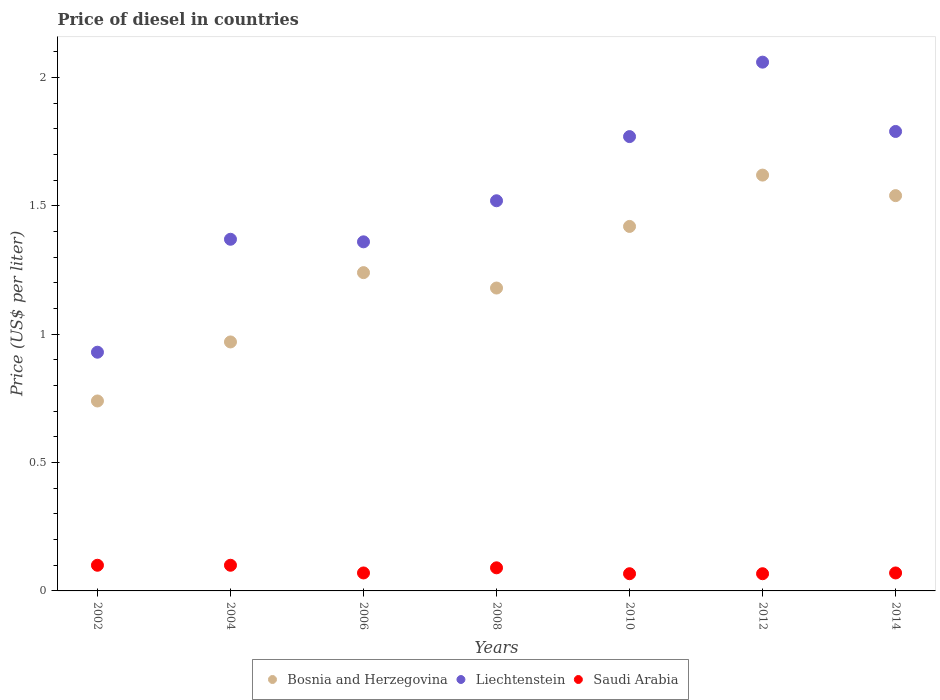How many different coloured dotlines are there?
Your answer should be very brief. 3. What is the price of diesel in Bosnia and Herzegovina in 2014?
Give a very brief answer. 1.54. Across all years, what is the maximum price of diesel in Bosnia and Herzegovina?
Your answer should be compact. 1.62. Across all years, what is the minimum price of diesel in Saudi Arabia?
Your response must be concise. 0.07. What is the total price of diesel in Bosnia and Herzegovina in the graph?
Keep it short and to the point. 8.71. What is the difference between the price of diesel in Saudi Arabia in 2006 and that in 2012?
Provide a succinct answer. 0. What is the difference between the price of diesel in Bosnia and Herzegovina in 2004 and the price of diesel in Saudi Arabia in 2012?
Your response must be concise. 0.9. What is the average price of diesel in Bosnia and Herzegovina per year?
Offer a terse response. 1.24. In the year 2014, what is the difference between the price of diesel in Saudi Arabia and price of diesel in Bosnia and Herzegovina?
Provide a succinct answer. -1.47. What is the ratio of the price of diesel in Bosnia and Herzegovina in 2002 to that in 2012?
Your answer should be compact. 0.46. Is the price of diesel in Saudi Arabia in 2002 less than that in 2014?
Provide a short and direct response. No. What is the difference between the highest and the second highest price of diesel in Liechtenstein?
Keep it short and to the point. 0.27. What is the difference between the highest and the lowest price of diesel in Saudi Arabia?
Your response must be concise. 0.03. In how many years, is the price of diesel in Bosnia and Herzegovina greater than the average price of diesel in Bosnia and Herzegovina taken over all years?
Provide a short and direct response. 3. Is it the case that in every year, the sum of the price of diesel in Bosnia and Herzegovina and price of diesel in Saudi Arabia  is greater than the price of diesel in Liechtenstein?
Offer a terse response. No. Does the price of diesel in Liechtenstein monotonically increase over the years?
Offer a very short reply. No. How many dotlines are there?
Your response must be concise. 3. How are the legend labels stacked?
Provide a succinct answer. Horizontal. What is the title of the graph?
Your answer should be very brief. Price of diesel in countries. What is the label or title of the X-axis?
Offer a very short reply. Years. What is the label or title of the Y-axis?
Offer a terse response. Price (US$ per liter). What is the Price (US$ per liter) of Bosnia and Herzegovina in 2002?
Provide a succinct answer. 0.74. What is the Price (US$ per liter) in Liechtenstein in 2002?
Offer a very short reply. 0.93. What is the Price (US$ per liter) in Saudi Arabia in 2002?
Offer a very short reply. 0.1. What is the Price (US$ per liter) of Bosnia and Herzegovina in 2004?
Offer a terse response. 0.97. What is the Price (US$ per liter) in Liechtenstein in 2004?
Ensure brevity in your answer.  1.37. What is the Price (US$ per liter) of Bosnia and Herzegovina in 2006?
Provide a short and direct response. 1.24. What is the Price (US$ per liter) in Liechtenstein in 2006?
Provide a short and direct response. 1.36. What is the Price (US$ per liter) of Saudi Arabia in 2006?
Offer a terse response. 0.07. What is the Price (US$ per liter) of Bosnia and Herzegovina in 2008?
Your answer should be compact. 1.18. What is the Price (US$ per liter) in Liechtenstein in 2008?
Offer a very short reply. 1.52. What is the Price (US$ per liter) in Saudi Arabia in 2008?
Your answer should be very brief. 0.09. What is the Price (US$ per liter) of Bosnia and Herzegovina in 2010?
Give a very brief answer. 1.42. What is the Price (US$ per liter) of Liechtenstein in 2010?
Provide a short and direct response. 1.77. What is the Price (US$ per liter) in Saudi Arabia in 2010?
Your response must be concise. 0.07. What is the Price (US$ per liter) in Bosnia and Herzegovina in 2012?
Make the answer very short. 1.62. What is the Price (US$ per liter) of Liechtenstein in 2012?
Offer a terse response. 2.06. What is the Price (US$ per liter) in Saudi Arabia in 2012?
Keep it short and to the point. 0.07. What is the Price (US$ per liter) in Bosnia and Herzegovina in 2014?
Make the answer very short. 1.54. What is the Price (US$ per liter) of Liechtenstein in 2014?
Provide a short and direct response. 1.79. What is the Price (US$ per liter) of Saudi Arabia in 2014?
Offer a terse response. 0.07. Across all years, what is the maximum Price (US$ per liter) in Bosnia and Herzegovina?
Keep it short and to the point. 1.62. Across all years, what is the maximum Price (US$ per liter) of Liechtenstein?
Ensure brevity in your answer.  2.06. Across all years, what is the maximum Price (US$ per liter) in Saudi Arabia?
Provide a succinct answer. 0.1. Across all years, what is the minimum Price (US$ per liter) of Bosnia and Herzegovina?
Provide a short and direct response. 0.74. Across all years, what is the minimum Price (US$ per liter) in Saudi Arabia?
Provide a short and direct response. 0.07. What is the total Price (US$ per liter) in Bosnia and Herzegovina in the graph?
Your response must be concise. 8.71. What is the total Price (US$ per liter) in Saudi Arabia in the graph?
Ensure brevity in your answer.  0.56. What is the difference between the Price (US$ per liter) in Bosnia and Herzegovina in 2002 and that in 2004?
Provide a succinct answer. -0.23. What is the difference between the Price (US$ per liter) of Liechtenstein in 2002 and that in 2004?
Your response must be concise. -0.44. What is the difference between the Price (US$ per liter) in Bosnia and Herzegovina in 2002 and that in 2006?
Offer a terse response. -0.5. What is the difference between the Price (US$ per liter) of Liechtenstein in 2002 and that in 2006?
Make the answer very short. -0.43. What is the difference between the Price (US$ per liter) in Saudi Arabia in 2002 and that in 2006?
Provide a succinct answer. 0.03. What is the difference between the Price (US$ per liter) in Bosnia and Herzegovina in 2002 and that in 2008?
Offer a terse response. -0.44. What is the difference between the Price (US$ per liter) in Liechtenstein in 2002 and that in 2008?
Your response must be concise. -0.59. What is the difference between the Price (US$ per liter) in Saudi Arabia in 2002 and that in 2008?
Ensure brevity in your answer.  0.01. What is the difference between the Price (US$ per liter) of Bosnia and Herzegovina in 2002 and that in 2010?
Keep it short and to the point. -0.68. What is the difference between the Price (US$ per liter) of Liechtenstein in 2002 and that in 2010?
Keep it short and to the point. -0.84. What is the difference between the Price (US$ per liter) in Saudi Arabia in 2002 and that in 2010?
Keep it short and to the point. 0.03. What is the difference between the Price (US$ per liter) of Bosnia and Herzegovina in 2002 and that in 2012?
Provide a succinct answer. -0.88. What is the difference between the Price (US$ per liter) of Liechtenstein in 2002 and that in 2012?
Your answer should be compact. -1.13. What is the difference between the Price (US$ per liter) of Saudi Arabia in 2002 and that in 2012?
Your answer should be very brief. 0.03. What is the difference between the Price (US$ per liter) in Liechtenstein in 2002 and that in 2014?
Keep it short and to the point. -0.86. What is the difference between the Price (US$ per liter) of Saudi Arabia in 2002 and that in 2014?
Your response must be concise. 0.03. What is the difference between the Price (US$ per liter) of Bosnia and Herzegovina in 2004 and that in 2006?
Ensure brevity in your answer.  -0.27. What is the difference between the Price (US$ per liter) of Bosnia and Herzegovina in 2004 and that in 2008?
Make the answer very short. -0.21. What is the difference between the Price (US$ per liter) of Saudi Arabia in 2004 and that in 2008?
Provide a succinct answer. 0.01. What is the difference between the Price (US$ per liter) in Bosnia and Herzegovina in 2004 and that in 2010?
Your answer should be compact. -0.45. What is the difference between the Price (US$ per liter) of Liechtenstein in 2004 and that in 2010?
Keep it short and to the point. -0.4. What is the difference between the Price (US$ per liter) in Saudi Arabia in 2004 and that in 2010?
Provide a succinct answer. 0.03. What is the difference between the Price (US$ per liter) in Bosnia and Herzegovina in 2004 and that in 2012?
Provide a succinct answer. -0.65. What is the difference between the Price (US$ per liter) in Liechtenstein in 2004 and that in 2012?
Your answer should be very brief. -0.69. What is the difference between the Price (US$ per liter) in Saudi Arabia in 2004 and that in 2012?
Ensure brevity in your answer.  0.03. What is the difference between the Price (US$ per liter) in Bosnia and Herzegovina in 2004 and that in 2014?
Keep it short and to the point. -0.57. What is the difference between the Price (US$ per liter) in Liechtenstein in 2004 and that in 2014?
Provide a succinct answer. -0.42. What is the difference between the Price (US$ per liter) of Saudi Arabia in 2004 and that in 2014?
Keep it short and to the point. 0.03. What is the difference between the Price (US$ per liter) of Liechtenstein in 2006 and that in 2008?
Keep it short and to the point. -0.16. What is the difference between the Price (US$ per liter) of Saudi Arabia in 2006 and that in 2008?
Offer a terse response. -0.02. What is the difference between the Price (US$ per liter) in Bosnia and Herzegovina in 2006 and that in 2010?
Provide a short and direct response. -0.18. What is the difference between the Price (US$ per liter) of Liechtenstein in 2006 and that in 2010?
Your answer should be compact. -0.41. What is the difference between the Price (US$ per liter) of Saudi Arabia in 2006 and that in 2010?
Ensure brevity in your answer.  0. What is the difference between the Price (US$ per liter) of Bosnia and Herzegovina in 2006 and that in 2012?
Offer a very short reply. -0.38. What is the difference between the Price (US$ per liter) in Saudi Arabia in 2006 and that in 2012?
Provide a short and direct response. 0. What is the difference between the Price (US$ per liter) in Bosnia and Herzegovina in 2006 and that in 2014?
Keep it short and to the point. -0.3. What is the difference between the Price (US$ per liter) of Liechtenstein in 2006 and that in 2014?
Your answer should be very brief. -0.43. What is the difference between the Price (US$ per liter) of Saudi Arabia in 2006 and that in 2014?
Make the answer very short. 0. What is the difference between the Price (US$ per liter) in Bosnia and Herzegovina in 2008 and that in 2010?
Provide a short and direct response. -0.24. What is the difference between the Price (US$ per liter) in Saudi Arabia in 2008 and that in 2010?
Your answer should be compact. 0.02. What is the difference between the Price (US$ per liter) in Bosnia and Herzegovina in 2008 and that in 2012?
Give a very brief answer. -0.44. What is the difference between the Price (US$ per liter) of Liechtenstein in 2008 and that in 2012?
Your response must be concise. -0.54. What is the difference between the Price (US$ per liter) in Saudi Arabia in 2008 and that in 2012?
Provide a short and direct response. 0.02. What is the difference between the Price (US$ per liter) of Bosnia and Herzegovina in 2008 and that in 2014?
Your response must be concise. -0.36. What is the difference between the Price (US$ per liter) in Liechtenstein in 2008 and that in 2014?
Your answer should be very brief. -0.27. What is the difference between the Price (US$ per liter) of Liechtenstein in 2010 and that in 2012?
Provide a succinct answer. -0.29. What is the difference between the Price (US$ per liter) of Saudi Arabia in 2010 and that in 2012?
Keep it short and to the point. 0. What is the difference between the Price (US$ per liter) of Bosnia and Herzegovina in 2010 and that in 2014?
Ensure brevity in your answer.  -0.12. What is the difference between the Price (US$ per liter) in Liechtenstein in 2010 and that in 2014?
Give a very brief answer. -0.02. What is the difference between the Price (US$ per liter) of Saudi Arabia in 2010 and that in 2014?
Offer a very short reply. -0. What is the difference between the Price (US$ per liter) in Bosnia and Herzegovina in 2012 and that in 2014?
Your answer should be compact. 0.08. What is the difference between the Price (US$ per liter) of Liechtenstein in 2012 and that in 2014?
Your answer should be very brief. 0.27. What is the difference between the Price (US$ per liter) of Saudi Arabia in 2012 and that in 2014?
Offer a very short reply. -0. What is the difference between the Price (US$ per liter) of Bosnia and Herzegovina in 2002 and the Price (US$ per liter) of Liechtenstein in 2004?
Offer a terse response. -0.63. What is the difference between the Price (US$ per liter) of Bosnia and Herzegovina in 2002 and the Price (US$ per liter) of Saudi Arabia in 2004?
Ensure brevity in your answer.  0.64. What is the difference between the Price (US$ per liter) in Liechtenstein in 2002 and the Price (US$ per liter) in Saudi Arabia in 2004?
Provide a succinct answer. 0.83. What is the difference between the Price (US$ per liter) of Bosnia and Herzegovina in 2002 and the Price (US$ per liter) of Liechtenstein in 2006?
Your response must be concise. -0.62. What is the difference between the Price (US$ per liter) in Bosnia and Herzegovina in 2002 and the Price (US$ per liter) in Saudi Arabia in 2006?
Your answer should be very brief. 0.67. What is the difference between the Price (US$ per liter) in Liechtenstein in 2002 and the Price (US$ per liter) in Saudi Arabia in 2006?
Offer a terse response. 0.86. What is the difference between the Price (US$ per liter) in Bosnia and Herzegovina in 2002 and the Price (US$ per liter) in Liechtenstein in 2008?
Ensure brevity in your answer.  -0.78. What is the difference between the Price (US$ per liter) in Bosnia and Herzegovina in 2002 and the Price (US$ per liter) in Saudi Arabia in 2008?
Your answer should be very brief. 0.65. What is the difference between the Price (US$ per liter) in Liechtenstein in 2002 and the Price (US$ per liter) in Saudi Arabia in 2008?
Offer a very short reply. 0.84. What is the difference between the Price (US$ per liter) in Bosnia and Herzegovina in 2002 and the Price (US$ per liter) in Liechtenstein in 2010?
Your answer should be compact. -1.03. What is the difference between the Price (US$ per liter) of Bosnia and Herzegovina in 2002 and the Price (US$ per liter) of Saudi Arabia in 2010?
Your answer should be compact. 0.67. What is the difference between the Price (US$ per liter) in Liechtenstein in 2002 and the Price (US$ per liter) in Saudi Arabia in 2010?
Your response must be concise. 0.86. What is the difference between the Price (US$ per liter) in Bosnia and Herzegovina in 2002 and the Price (US$ per liter) in Liechtenstein in 2012?
Your response must be concise. -1.32. What is the difference between the Price (US$ per liter) in Bosnia and Herzegovina in 2002 and the Price (US$ per liter) in Saudi Arabia in 2012?
Keep it short and to the point. 0.67. What is the difference between the Price (US$ per liter) of Liechtenstein in 2002 and the Price (US$ per liter) of Saudi Arabia in 2012?
Your answer should be compact. 0.86. What is the difference between the Price (US$ per liter) of Bosnia and Herzegovina in 2002 and the Price (US$ per liter) of Liechtenstein in 2014?
Your answer should be very brief. -1.05. What is the difference between the Price (US$ per liter) of Bosnia and Herzegovina in 2002 and the Price (US$ per liter) of Saudi Arabia in 2014?
Ensure brevity in your answer.  0.67. What is the difference between the Price (US$ per liter) of Liechtenstein in 2002 and the Price (US$ per liter) of Saudi Arabia in 2014?
Your response must be concise. 0.86. What is the difference between the Price (US$ per liter) in Bosnia and Herzegovina in 2004 and the Price (US$ per liter) in Liechtenstein in 2006?
Offer a very short reply. -0.39. What is the difference between the Price (US$ per liter) in Liechtenstein in 2004 and the Price (US$ per liter) in Saudi Arabia in 2006?
Provide a succinct answer. 1.3. What is the difference between the Price (US$ per liter) in Bosnia and Herzegovina in 2004 and the Price (US$ per liter) in Liechtenstein in 2008?
Give a very brief answer. -0.55. What is the difference between the Price (US$ per liter) of Liechtenstein in 2004 and the Price (US$ per liter) of Saudi Arabia in 2008?
Your response must be concise. 1.28. What is the difference between the Price (US$ per liter) in Bosnia and Herzegovina in 2004 and the Price (US$ per liter) in Saudi Arabia in 2010?
Offer a very short reply. 0.9. What is the difference between the Price (US$ per liter) in Liechtenstein in 2004 and the Price (US$ per liter) in Saudi Arabia in 2010?
Your answer should be compact. 1.3. What is the difference between the Price (US$ per liter) of Bosnia and Herzegovina in 2004 and the Price (US$ per liter) of Liechtenstein in 2012?
Provide a short and direct response. -1.09. What is the difference between the Price (US$ per liter) in Bosnia and Herzegovina in 2004 and the Price (US$ per liter) in Saudi Arabia in 2012?
Ensure brevity in your answer.  0.9. What is the difference between the Price (US$ per liter) of Liechtenstein in 2004 and the Price (US$ per liter) of Saudi Arabia in 2012?
Your answer should be very brief. 1.3. What is the difference between the Price (US$ per liter) in Bosnia and Herzegovina in 2004 and the Price (US$ per liter) in Liechtenstein in 2014?
Your answer should be compact. -0.82. What is the difference between the Price (US$ per liter) of Bosnia and Herzegovina in 2004 and the Price (US$ per liter) of Saudi Arabia in 2014?
Offer a terse response. 0.9. What is the difference between the Price (US$ per liter) of Bosnia and Herzegovina in 2006 and the Price (US$ per liter) of Liechtenstein in 2008?
Offer a very short reply. -0.28. What is the difference between the Price (US$ per liter) in Bosnia and Herzegovina in 2006 and the Price (US$ per liter) in Saudi Arabia in 2008?
Make the answer very short. 1.15. What is the difference between the Price (US$ per liter) of Liechtenstein in 2006 and the Price (US$ per liter) of Saudi Arabia in 2008?
Offer a very short reply. 1.27. What is the difference between the Price (US$ per liter) in Bosnia and Herzegovina in 2006 and the Price (US$ per liter) in Liechtenstein in 2010?
Your response must be concise. -0.53. What is the difference between the Price (US$ per liter) in Bosnia and Herzegovina in 2006 and the Price (US$ per liter) in Saudi Arabia in 2010?
Offer a very short reply. 1.17. What is the difference between the Price (US$ per liter) in Liechtenstein in 2006 and the Price (US$ per liter) in Saudi Arabia in 2010?
Provide a short and direct response. 1.29. What is the difference between the Price (US$ per liter) of Bosnia and Herzegovina in 2006 and the Price (US$ per liter) of Liechtenstein in 2012?
Keep it short and to the point. -0.82. What is the difference between the Price (US$ per liter) of Bosnia and Herzegovina in 2006 and the Price (US$ per liter) of Saudi Arabia in 2012?
Offer a terse response. 1.17. What is the difference between the Price (US$ per liter) in Liechtenstein in 2006 and the Price (US$ per liter) in Saudi Arabia in 2012?
Offer a very short reply. 1.29. What is the difference between the Price (US$ per liter) in Bosnia and Herzegovina in 2006 and the Price (US$ per liter) in Liechtenstein in 2014?
Offer a very short reply. -0.55. What is the difference between the Price (US$ per liter) in Bosnia and Herzegovina in 2006 and the Price (US$ per liter) in Saudi Arabia in 2014?
Offer a terse response. 1.17. What is the difference between the Price (US$ per liter) in Liechtenstein in 2006 and the Price (US$ per liter) in Saudi Arabia in 2014?
Offer a terse response. 1.29. What is the difference between the Price (US$ per liter) of Bosnia and Herzegovina in 2008 and the Price (US$ per liter) of Liechtenstein in 2010?
Give a very brief answer. -0.59. What is the difference between the Price (US$ per liter) of Bosnia and Herzegovina in 2008 and the Price (US$ per liter) of Saudi Arabia in 2010?
Offer a very short reply. 1.11. What is the difference between the Price (US$ per liter) of Liechtenstein in 2008 and the Price (US$ per liter) of Saudi Arabia in 2010?
Provide a succinct answer. 1.45. What is the difference between the Price (US$ per liter) of Bosnia and Herzegovina in 2008 and the Price (US$ per liter) of Liechtenstein in 2012?
Your response must be concise. -0.88. What is the difference between the Price (US$ per liter) in Bosnia and Herzegovina in 2008 and the Price (US$ per liter) in Saudi Arabia in 2012?
Ensure brevity in your answer.  1.11. What is the difference between the Price (US$ per liter) in Liechtenstein in 2008 and the Price (US$ per liter) in Saudi Arabia in 2012?
Keep it short and to the point. 1.45. What is the difference between the Price (US$ per liter) in Bosnia and Herzegovina in 2008 and the Price (US$ per liter) in Liechtenstein in 2014?
Your answer should be very brief. -0.61. What is the difference between the Price (US$ per liter) in Bosnia and Herzegovina in 2008 and the Price (US$ per liter) in Saudi Arabia in 2014?
Keep it short and to the point. 1.11. What is the difference between the Price (US$ per liter) in Liechtenstein in 2008 and the Price (US$ per liter) in Saudi Arabia in 2014?
Your response must be concise. 1.45. What is the difference between the Price (US$ per liter) in Bosnia and Herzegovina in 2010 and the Price (US$ per liter) in Liechtenstein in 2012?
Provide a succinct answer. -0.64. What is the difference between the Price (US$ per liter) in Bosnia and Herzegovina in 2010 and the Price (US$ per liter) in Saudi Arabia in 2012?
Ensure brevity in your answer.  1.35. What is the difference between the Price (US$ per liter) of Liechtenstein in 2010 and the Price (US$ per liter) of Saudi Arabia in 2012?
Your answer should be compact. 1.7. What is the difference between the Price (US$ per liter) in Bosnia and Herzegovina in 2010 and the Price (US$ per liter) in Liechtenstein in 2014?
Give a very brief answer. -0.37. What is the difference between the Price (US$ per liter) in Bosnia and Herzegovina in 2010 and the Price (US$ per liter) in Saudi Arabia in 2014?
Provide a short and direct response. 1.35. What is the difference between the Price (US$ per liter) of Bosnia and Herzegovina in 2012 and the Price (US$ per liter) of Liechtenstein in 2014?
Your answer should be very brief. -0.17. What is the difference between the Price (US$ per liter) of Bosnia and Herzegovina in 2012 and the Price (US$ per liter) of Saudi Arabia in 2014?
Provide a succinct answer. 1.55. What is the difference between the Price (US$ per liter) of Liechtenstein in 2012 and the Price (US$ per liter) of Saudi Arabia in 2014?
Provide a succinct answer. 1.99. What is the average Price (US$ per liter) of Bosnia and Herzegovina per year?
Your response must be concise. 1.24. What is the average Price (US$ per liter) in Liechtenstein per year?
Your answer should be compact. 1.54. What is the average Price (US$ per liter) of Saudi Arabia per year?
Your answer should be compact. 0.08. In the year 2002, what is the difference between the Price (US$ per liter) in Bosnia and Herzegovina and Price (US$ per liter) in Liechtenstein?
Your answer should be very brief. -0.19. In the year 2002, what is the difference between the Price (US$ per liter) in Bosnia and Herzegovina and Price (US$ per liter) in Saudi Arabia?
Offer a terse response. 0.64. In the year 2002, what is the difference between the Price (US$ per liter) in Liechtenstein and Price (US$ per liter) in Saudi Arabia?
Provide a succinct answer. 0.83. In the year 2004, what is the difference between the Price (US$ per liter) of Bosnia and Herzegovina and Price (US$ per liter) of Liechtenstein?
Provide a short and direct response. -0.4. In the year 2004, what is the difference between the Price (US$ per liter) in Bosnia and Herzegovina and Price (US$ per liter) in Saudi Arabia?
Your answer should be compact. 0.87. In the year 2004, what is the difference between the Price (US$ per liter) of Liechtenstein and Price (US$ per liter) of Saudi Arabia?
Offer a very short reply. 1.27. In the year 2006, what is the difference between the Price (US$ per liter) in Bosnia and Herzegovina and Price (US$ per liter) in Liechtenstein?
Ensure brevity in your answer.  -0.12. In the year 2006, what is the difference between the Price (US$ per liter) in Bosnia and Herzegovina and Price (US$ per liter) in Saudi Arabia?
Your answer should be very brief. 1.17. In the year 2006, what is the difference between the Price (US$ per liter) of Liechtenstein and Price (US$ per liter) of Saudi Arabia?
Offer a very short reply. 1.29. In the year 2008, what is the difference between the Price (US$ per liter) in Bosnia and Herzegovina and Price (US$ per liter) in Liechtenstein?
Offer a terse response. -0.34. In the year 2008, what is the difference between the Price (US$ per liter) in Bosnia and Herzegovina and Price (US$ per liter) in Saudi Arabia?
Keep it short and to the point. 1.09. In the year 2008, what is the difference between the Price (US$ per liter) of Liechtenstein and Price (US$ per liter) of Saudi Arabia?
Ensure brevity in your answer.  1.43. In the year 2010, what is the difference between the Price (US$ per liter) in Bosnia and Herzegovina and Price (US$ per liter) in Liechtenstein?
Offer a terse response. -0.35. In the year 2010, what is the difference between the Price (US$ per liter) in Bosnia and Herzegovina and Price (US$ per liter) in Saudi Arabia?
Ensure brevity in your answer.  1.35. In the year 2010, what is the difference between the Price (US$ per liter) of Liechtenstein and Price (US$ per liter) of Saudi Arabia?
Ensure brevity in your answer.  1.7. In the year 2012, what is the difference between the Price (US$ per liter) in Bosnia and Herzegovina and Price (US$ per liter) in Liechtenstein?
Give a very brief answer. -0.44. In the year 2012, what is the difference between the Price (US$ per liter) of Bosnia and Herzegovina and Price (US$ per liter) of Saudi Arabia?
Your answer should be compact. 1.55. In the year 2012, what is the difference between the Price (US$ per liter) of Liechtenstein and Price (US$ per liter) of Saudi Arabia?
Your answer should be very brief. 1.99. In the year 2014, what is the difference between the Price (US$ per liter) in Bosnia and Herzegovina and Price (US$ per liter) in Liechtenstein?
Keep it short and to the point. -0.25. In the year 2014, what is the difference between the Price (US$ per liter) in Bosnia and Herzegovina and Price (US$ per liter) in Saudi Arabia?
Provide a succinct answer. 1.47. In the year 2014, what is the difference between the Price (US$ per liter) in Liechtenstein and Price (US$ per liter) in Saudi Arabia?
Provide a short and direct response. 1.72. What is the ratio of the Price (US$ per liter) in Bosnia and Herzegovina in 2002 to that in 2004?
Offer a terse response. 0.76. What is the ratio of the Price (US$ per liter) of Liechtenstein in 2002 to that in 2004?
Ensure brevity in your answer.  0.68. What is the ratio of the Price (US$ per liter) of Saudi Arabia in 2002 to that in 2004?
Give a very brief answer. 1. What is the ratio of the Price (US$ per liter) in Bosnia and Herzegovina in 2002 to that in 2006?
Ensure brevity in your answer.  0.6. What is the ratio of the Price (US$ per liter) in Liechtenstein in 2002 to that in 2006?
Make the answer very short. 0.68. What is the ratio of the Price (US$ per liter) of Saudi Arabia in 2002 to that in 2006?
Provide a succinct answer. 1.43. What is the ratio of the Price (US$ per liter) of Bosnia and Herzegovina in 2002 to that in 2008?
Make the answer very short. 0.63. What is the ratio of the Price (US$ per liter) in Liechtenstein in 2002 to that in 2008?
Ensure brevity in your answer.  0.61. What is the ratio of the Price (US$ per liter) in Saudi Arabia in 2002 to that in 2008?
Ensure brevity in your answer.  1.11. What is the ratio of the Price (US$ per liter) in Bosnia and Herzegovina in 2002 to that in 2010?
Provide a succinct answer. 0.52. What is the ratio of the Price (US$ per liter) in Liechtenstein in 2002 to that in 2010?
Your answer should be compact. 0.53. What is the ratio of the Price (US$ per liter) of Saudi Arabia in 2002 to that in 2010?
Your answer should be compact. 1.49. What is the ratio of the Price (US$ per liter) of Bosnia and Herzegovina in 2002 to that in 2012?
Offer a very short reply. 0.46. What is the ratio of the Price (US$ per liter) in Liechtenstein in 2002 to that in 2012?
Offer a terse response. 0.45. What is the ratio of the Price (US$ per liter) of Saudi Arabia in 2002 to that in 2012?
Offer a very short reply. 1.49. What is the ratio of the Price (US$ per liter) of Bosnia and Herzegovina in 2002 to that in 2014?
Offer a very short reply. 0.48. What is the ratio of the Price (US$ per liter) in Liechtenstein in 2002 to that in 2014?
Keep it short and to the point. 0.52. What is the ratio of the Price (US$ per liter) in Saudi Arabia in 2002 to that in 2014?
Offer a terse response. 1.43. What is the ratio of the Price (US$ per liter) of Bosnia and Herzegovina in 2004 to that in 2006?
Keep it short and to the point. 0.78. What is the ratio of the Price (US$ per liter) in Liechtenstein in 2004 to that in 2006?
Your answer should be very brief. 1.01. What is the ratio of the Price (US$ per liter) in Saudi Arabia in 2004 to that in 2006?
Provide a short and direct response. 1.43. What is the ratio of the Price (US$ per liter) in Bosnia and Herzegovina in 2004 to that in 2008?
Provide a succinct answer. 0.82. What is the ratio of the Price (US$ per liter) of Liechtenstein in 2004 to that in 2008?
Make the answer very short. 0.9. What is the ratio of the Price (US$ per liter) of Saudi Arabia in 2004 to that in 2008?
Offer a terse response. 1.11. What is the ratio of the Price (US$ per liter) of Bosnia and Herzegovina in 2004 to that in 2010?
Offer a terse response. 0.68. What is the ratio of the Price (US$ per liter) of Liechtenstein in 2004 to that in 2010?
Provide a short and direct response. 0.77. What is the ratio of the Price (US$ per liter) of Saudi Arabia in 2004 to that in 2010?
Offer a very short reply. 1.49. What is the ratio of the Price (US$ per liter) in Bosnia and Herzegovina in 2004 to that in 2012?
Your answer should be compact. 0.6. What is the ratio of the Price (US$ per liter) in Liechtenstein in 2004 to that in 2012?
Give a very brief answer. 0.67. What is the ratio of the Price (US$ per liter) of Saudi Arabia in 2004 to that in 2012?
Give a very brief answer. 1.49. What is the ratio of the Price (US$ per liter) in Bosnia and Herzegovina in 2004 to that in 2014?
Provide a short and direct response. 0.63. What is the ratio of the Price (US$ per liter) of Liechtenstein in 2004 to that in 2014?
Provide a succinct answer. 0.77. What is the ratio of the Price (US$ per liter) in Saudi Arabia in 2004 to that in 2014?
Provide a succinct answer. 1.43. What is the ratio of the Price (US$ per liter) in Bosnia and Herzegovina in 2006 to that in 2008?
Your response must be concise. 1.05. What is the ratio of the Price (US$ per liter) of Liechtenstein in 2006 to that in 2008?
Make the answer very short. 0.89. What is the ratio of the Price (US$ per liter) of Bosnia and Herzegovina in 2006 to that in 2010?
Provide a succinct answer. 0.87. What is the ratio of the Price (US$ per liter) in Liechtenstein in 2006 to that in 2010?
Keep it short and to the point. 0.77. What is the ratio of the Price (US$ per liter) of Saudi Arabia in 2006 to that in 2010?
Ensure brevity in your answer.  1.04. What is the ratio of the Price (US$ per liter) in Bosnia and Herzegovina in 2006 to that in 2012?
Make the answer very short. 0.77. What is the ratio of the Price (US$ per liter) of Liechtenstein in 2006 to that in 2012?
Ensure brevity in your answer.  0.66. What is the ratio of the Price (US$ per liter) of Saudi Arabia in 2006 to that in 2012?
Keep it short and to the point. 1.04. What is the ratio of the Price (US$ per liter) of Bosnia and Herzegovina in 2006 to that in 2014?
Offer a very short reply. 0.81. What is the ratio of the Price (US$ per liter) in Liechtenstein in 2006 to that in 2014?
Give a very brief answer. 0.76. What is the ratio of the Price (US$ per liter) in Saudi Arabia in 2006 to that in 2014?
Your answer should be very brief. 1. What is the ratio of the Price (US$ per liter) in Bosnia and Herzegovina in 2008 to that in 2010?
Offer a very short reply. 0.83. What is the ratio of the Price (US$ per liter) in Liechtenstein in 2008 to that in 2010?
Keep it short and to the point. 0.86. What is the ratio of the Price (US$ per liter) in Saudi Arabia in 2008 to that in 2010?
Make the answer very short. 1.34. What is the ratio of the Price (US$ per liter) of Bosnia and Herzegovina in 2008 to that in 2012?
Give a very brief answer. 0.73. What is the ratio of the Price (US$ per liter) in Liechtenstein in 2008 to that in 2012?
Your answer should be compact. 0.74. What is the ratio of the Price (US$ per liter) in Saudi Arabia in 2008 to that in 2012?
Your response must be concise. 1.34. What is the ratio of the Price (US$ per liter) of Bosnia and Herzegovina in 2008 to that in 2014?
Your answer should be compact. 0.77. What is the ratio of the Price (US$ per liter) of Liechtenstein in 2008 to that in 2014?
Ensure brevity in your answer.  0.85. What is the ratio of the Price (US$ per liter) of Saudi Arabia in 2008 to that in 2014?
Provide a succinct answer. 1.29. What is the ratio of the Price (US$ per liter) in Bosnia and Herzegovina in 2010 to that in 2012?
Offer a very short reply. 0.88. What is the ratio of the Price (US$ per liter) of Liechtenstein in 2010 to that in 2012?
Provide a short and direct response. 0.86. What is the ratio of the Price (US$ per liter) in Bosnia and Herzegovina in 2010 to that in 2014?
Make the answer very short. 0.92. What is the ratio of the Price (US$ per liter) in Liechtenstein in 2010 to that in 2014?
Your answer should be very brief. 0.99. What is the ratio of the Price (US$ per liter) of Saudi Arabia in 2010 to that in 2014?
Give a very brief answer. 0.96. What is the ratio of the Price (US$ per liter) of Bosnia and Herzegovina in 2012 to that in 2014?
Keep it short and to the point. 1.05. What is the ratio of the Price (US$ per liter) in Liechtenstein in 2012 to that in 2014?
Ensure brevity in your answer.  1.15. What is the ratio of the Price (US$ per liter) in Saudi Arabia in 2012 to that in 2014?
Offer a very short reply. 0.96. What is the difference between the highest and the second highest Price (US$ per liter) of Liechtenstein?
Offer a terse response. 0.27. What is the difference between the highest and the lowest Price (US$ per liter) of Liechtenstein?
Make the answer very short. 1.13. What is the difference between the highest and the lowest Price (US$ per liter) of Saudi Arabia?
Ensure brevity in your answer.  0.03. 